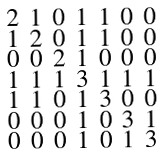Convert formula to latex. <formula><loc_0><loc_0><loc_500><loc_500>\begin{smallmatrix} 2 & 1 & 0 & 1 & 1 & 0 & 0 \\ 1 & 2 & 0 & 1 & 1 & 0 & 0 \\ 0 & 0 & 2 & 1 & 0 & 0 & 0 \\ 1 & 1 & 1 & 3 & 1 & 1 & 1 \\ 1 & 1 & 0 & 1 & 3 & 0 & 0 \\ 0 & 0 & 0 & 1 & 0 & 3 & 1 \\ 0 & 0 & 0 & 1 & 0 & 1 & 3 \end{smallmatrix}</formula> 